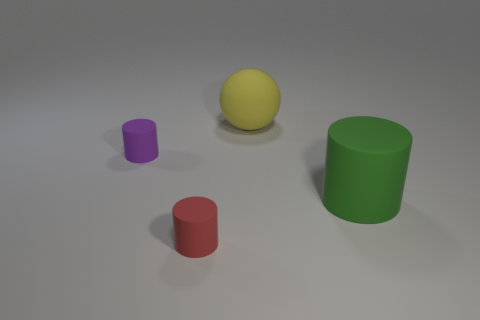Subtract all tiny red matte cylinders. How many cylinders are left? 2 Add 1 tiny red cylinders. How many objects exist? 5 Subtract all cylinders. How many objects are left? 1 Subtract all purple balls. Subtract all yellow cubes. How many balls are left? 1 Subtract all small rubber cylinders. Subtract all large green cylinders. How many objects are left? 1 Add 4 big yellow balls. How many big yellow balls are left? 5 Add 2 purple things. How many purple things exist? 3 Subtract 1 purple cylinders. How many objects are left? 3 